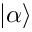Convert formula to latex. <formula><loc_0><loc_0><loc_500><loc_500>| \alpha \rangle</formula> 